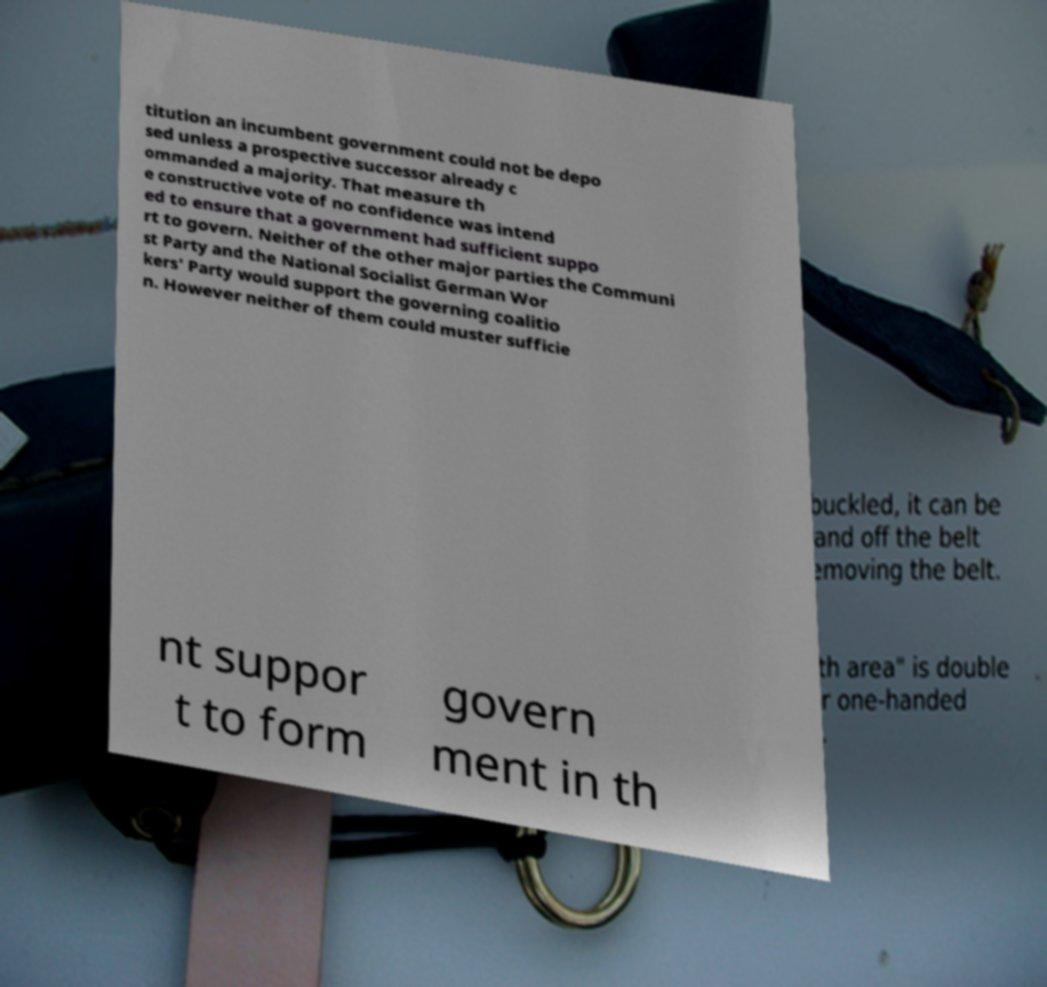For documentation purposes, I need the text within this image transcribed. Could you provide that? titution an incumbent government could not be depo sed unless a prospective successor already c ommanded a majority. That measure th e constructive vote of no confidence was intend ed to ensure that a government had sufficient suppo rt to govern. Neither of the other major parties the Communi st Party and the National Socialist German Wor kers' Party would support the governing coalitio n. However neither of them could muster sufficie nt suppor t to form govern ment in th 